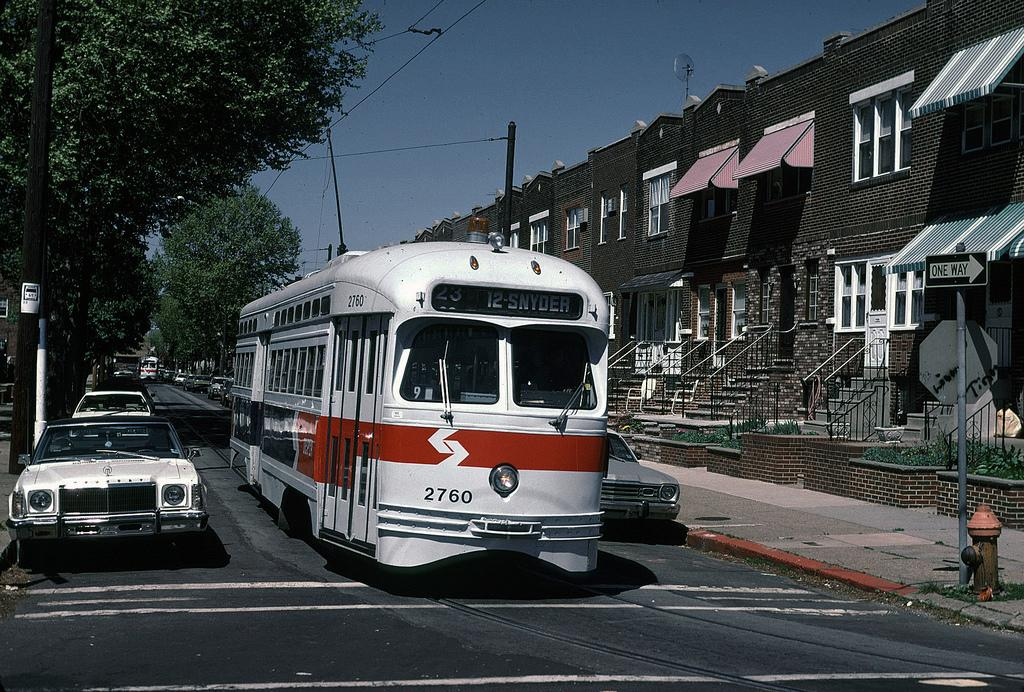What type of structures can be seen in the image? There are buildings in the image. What features do the buildings have? The buildings have windows. Can you describe any architectural elements in the image? There are stairs, railing, and poles in the image. What is the purpose of the signboard in the image? The purpose of the signboard is to provide information or directions. What is the function of the fire-hydrant in the image? The fire-hydrant is used for firefighting purposes. What type of vegetation is present in the image? There are trees in the image. What part of the natural environment is visible in the image? The sky is visible in the image. What type of transportation can be seen on the road in the image? There are vehicles on the road in the image. Where are the bushes located in the image? There are no bushes present in the image. What type of copy is being made in the image? There is no copying activity depicted in the image. 